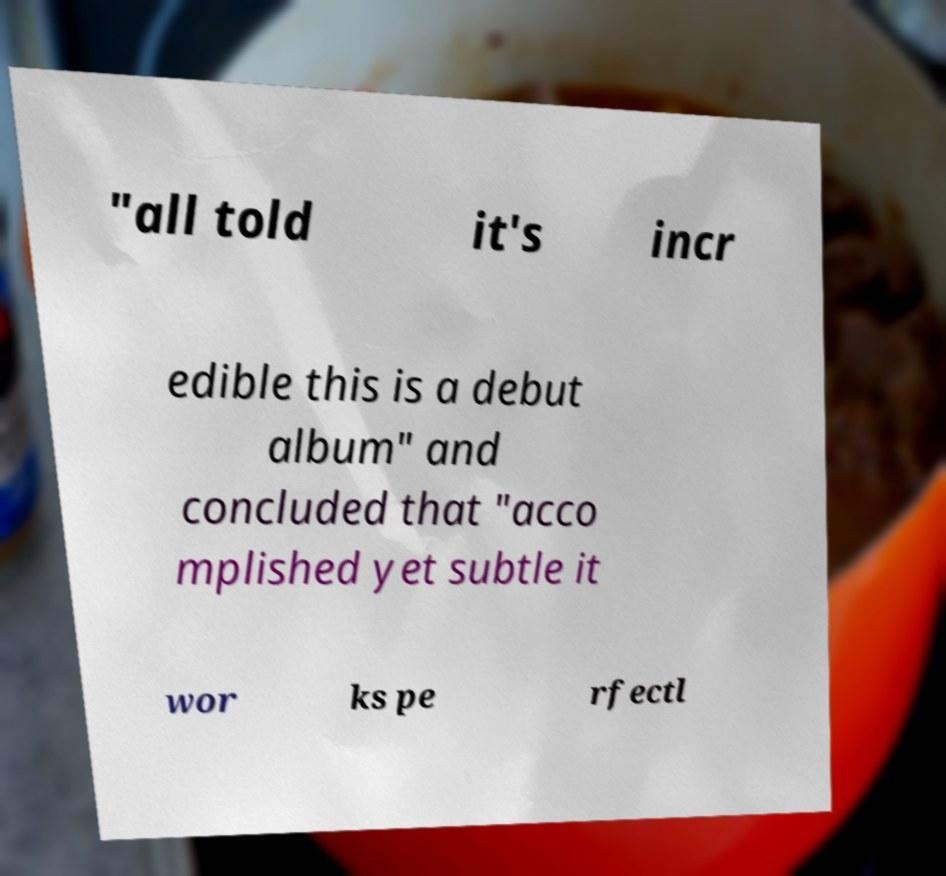Can you read and provide the text displayed in the image?This photo seems to have some interesting text. Can you extract and type it out for me? "all told it's incr edible this is a debut album" and concluded that "acco mplished yet subtle it wor ks pe rfectl 